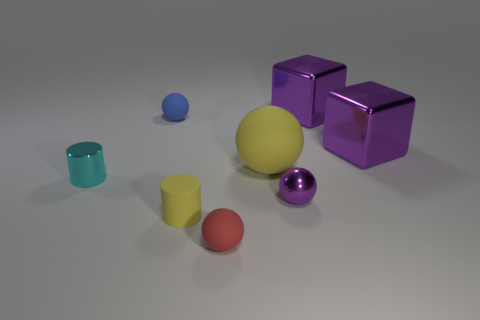There is a metallic object that is in front of the large yellow matte ball and right of the red thing; what color is it?
Your answer should be very brief. Purple. The yellow sphere has what size?
Your response must be concise. Large. How many metallic spheres are the same size as the red rubber thing?
Make the answer very short. 1. Is the material of the large cube behind the blue rubber thing the same as the cylinder that is on the left side of the small yellow cylinder?
Your answer should be very brief. Yes. There is a small blue thing that is behind the yellow thing behind the small metallic cylinder; what is its material?
Offer a terse response. Rubber. What is the tiny sphere that is on the left side of the small red thing made of?
Provide a succinct answer. Rubber. What number of green metal things are the same shape as the small blue rubber thing?
Give a very brief answer. 0. Is the tiny rubber cylinder the same color as the large matte ball?
Ensure brevity in your answer.  Yes. What material is the big object on the left side of the metal thing behind the tiny rubber ball on the left side of the red rubber sphere made of?
Your response must be concise. Rubber. There is a small shiny ball; are there any tiny things behind it?
Give a very brief answer. Yes. 